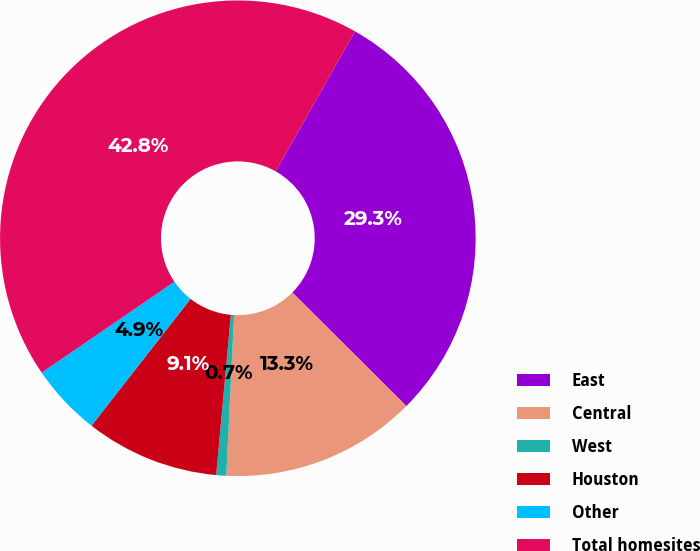Convert chart. <chart><loc_0><loc_0><loc_500><loc_500><pie_chart><fcel>East<fcel>Central<fcel>West<fcel>Houston<fcel>Other<fcel>Total homesites<nl><fcel>29.27%<fcel>13.31%<fcel>0.68%<fcel>9.1%<fcel>4.89%<fcel>42.76%<nl></chart> 